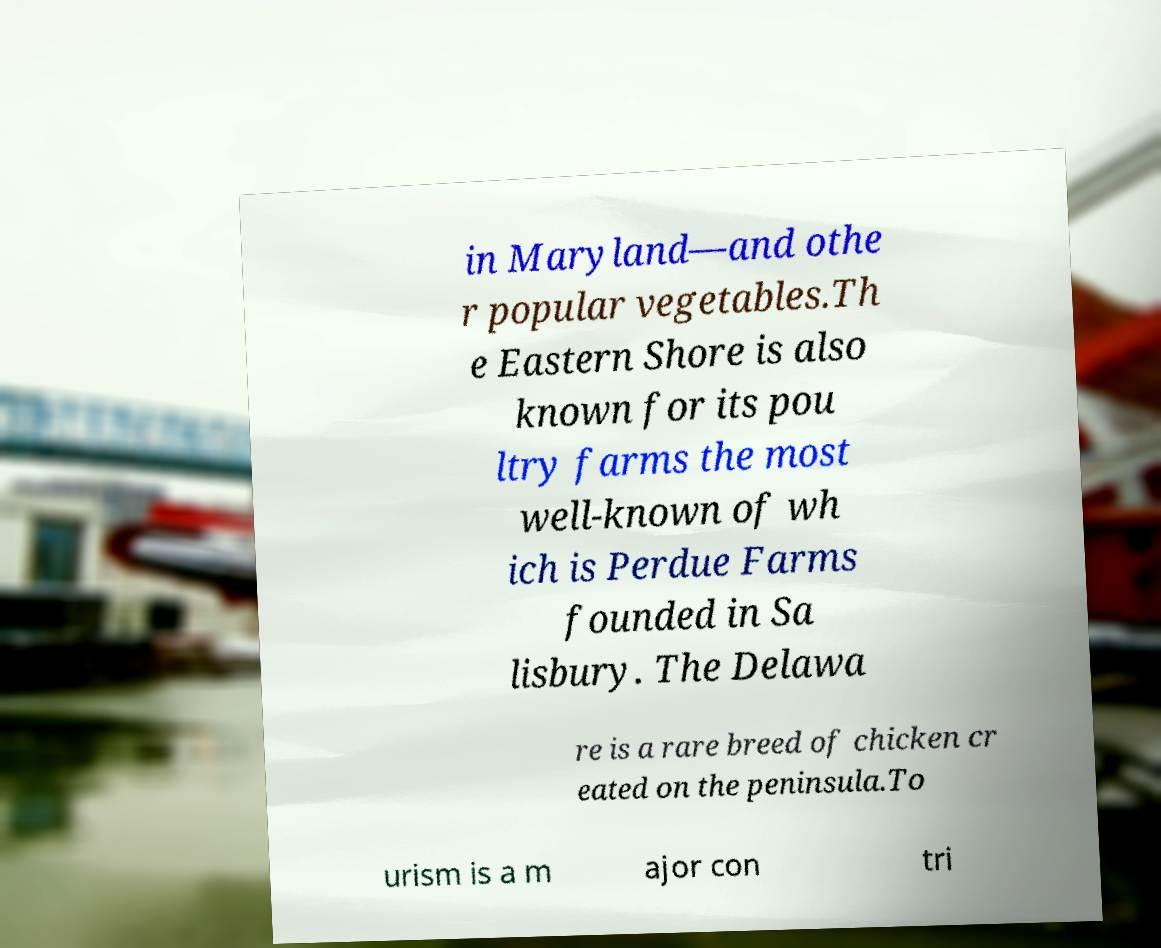Could you extract and type out the text from this image? in Maryland—and othe r popular vegetables.Th e Eastern Shore is also known for its pou ltry farms the most well-known of wh ich is Perdue Farms founded in Sa lisbury. The Delawa re is a rare breed of chicken cr eated on the peninsula.To urism is a m ajor con tri 